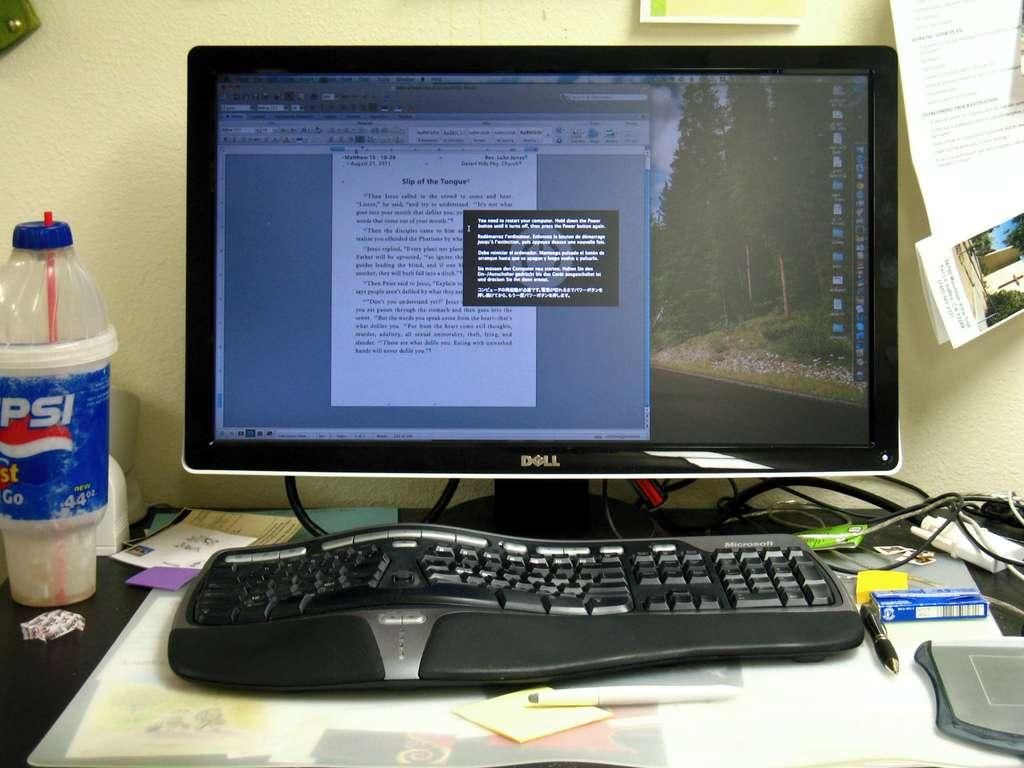<image>
Share a concise interpretation of the image provided. a Dell desk top computer monitor open to a document page 